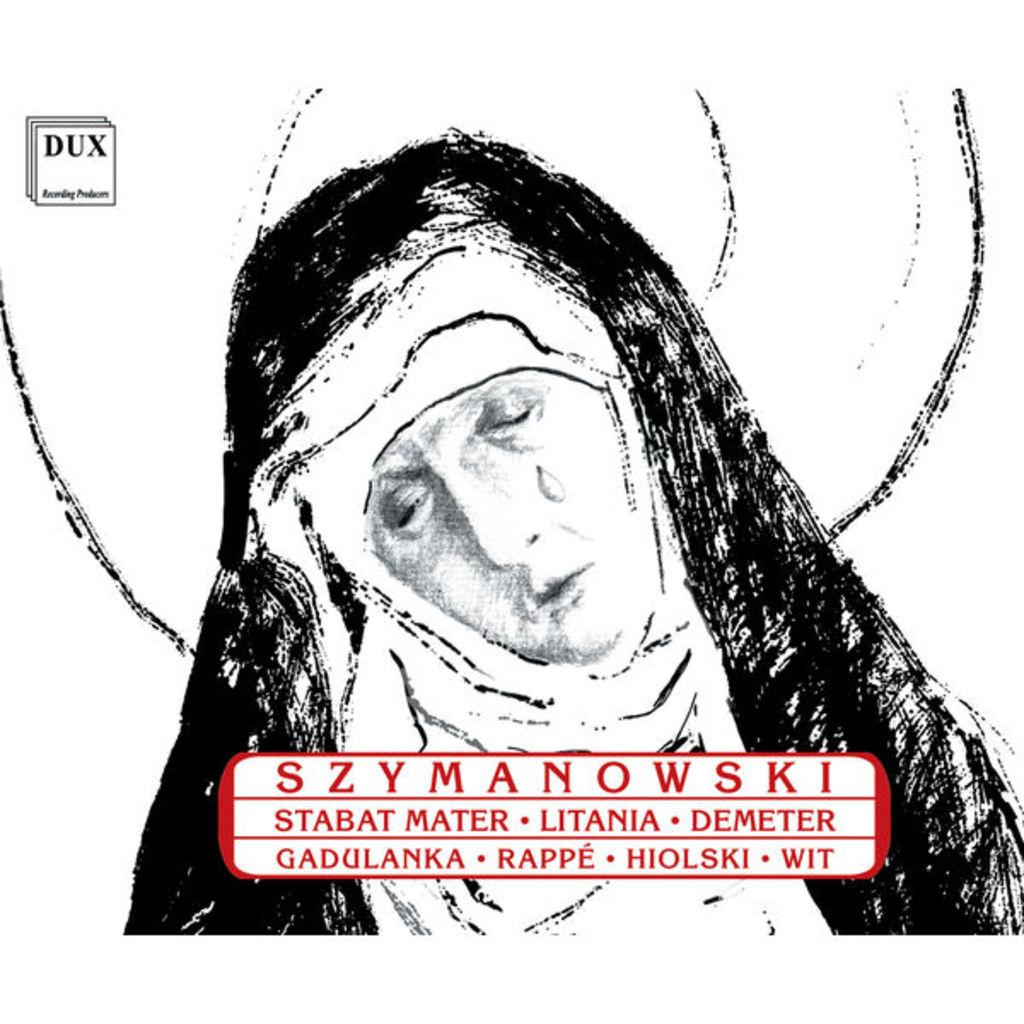What is the main subject of the painting? The painting depicts a woman. What is the woman doing in the painting? The woman is bending her head towards the left and crying. What can be seen on the woman in the painting? There is a black-colored cloth on the woman. Where is the crate located in the painting? There is no crate present in the painting. What type of books can be seen on the woman's lap in the painting? There are no books present in the painting; the woman is depicted with a black-colored cloth on her. 